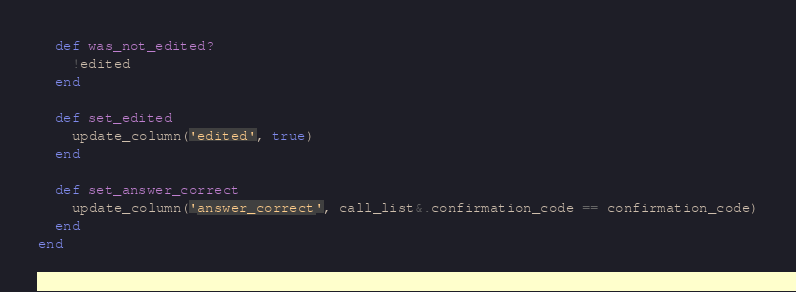Convert code to text. <code><loc_0><loc_0><loc_500><loc_500><_Ruby_>
  def was_not_edited?
    !edited
  end

  def set_edited
    update_column('edited', true)
  end

  def set_answer_correct
    update_column('answer_correct', call_list&.confirmation_code == confirmation_code)
  end
end
</code> 